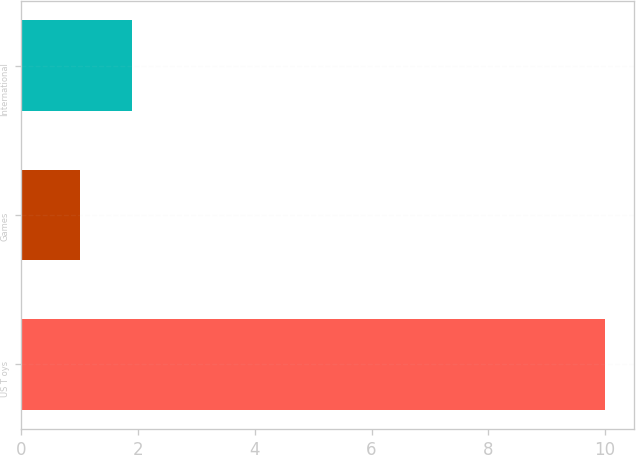<chart> <loc_0><loc_0><loc_500><loc_500><bar_chart><fcel>US T oys<fcel>Games<fcel>International<nl><fcel>10<fcel>1<fcel>1.9<nl></chart> 